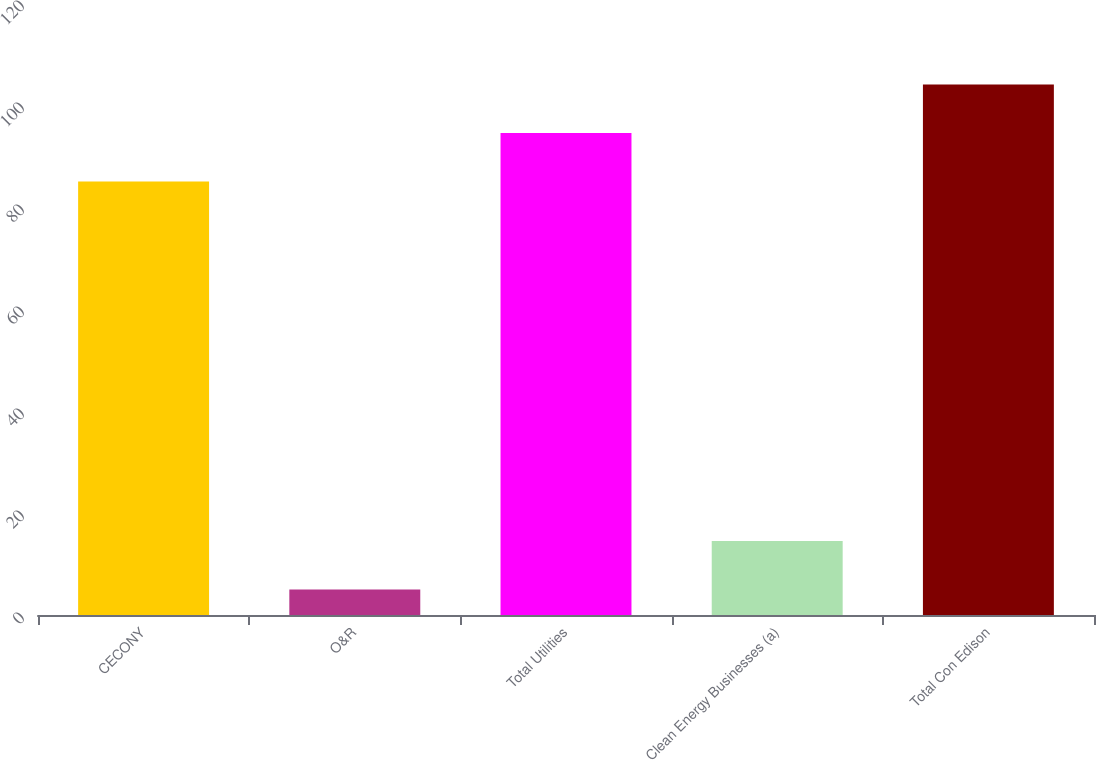Convert chart. <chart><loc_0><loc_0><loc_500><loc_500><bar_chart><fcel>CECONY<fcel>O&R<fcel>Total Utilities<fcel>Clean Energy Businesses (a)<fcel>Total Con Edison<nl><fcel>85<fcel>5<fcel>94.5<fcel>14.5<fcel>104<nl></chart> 